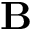<formula> <loc_0><loc_0><loc_500><loc_500>B</formula> 